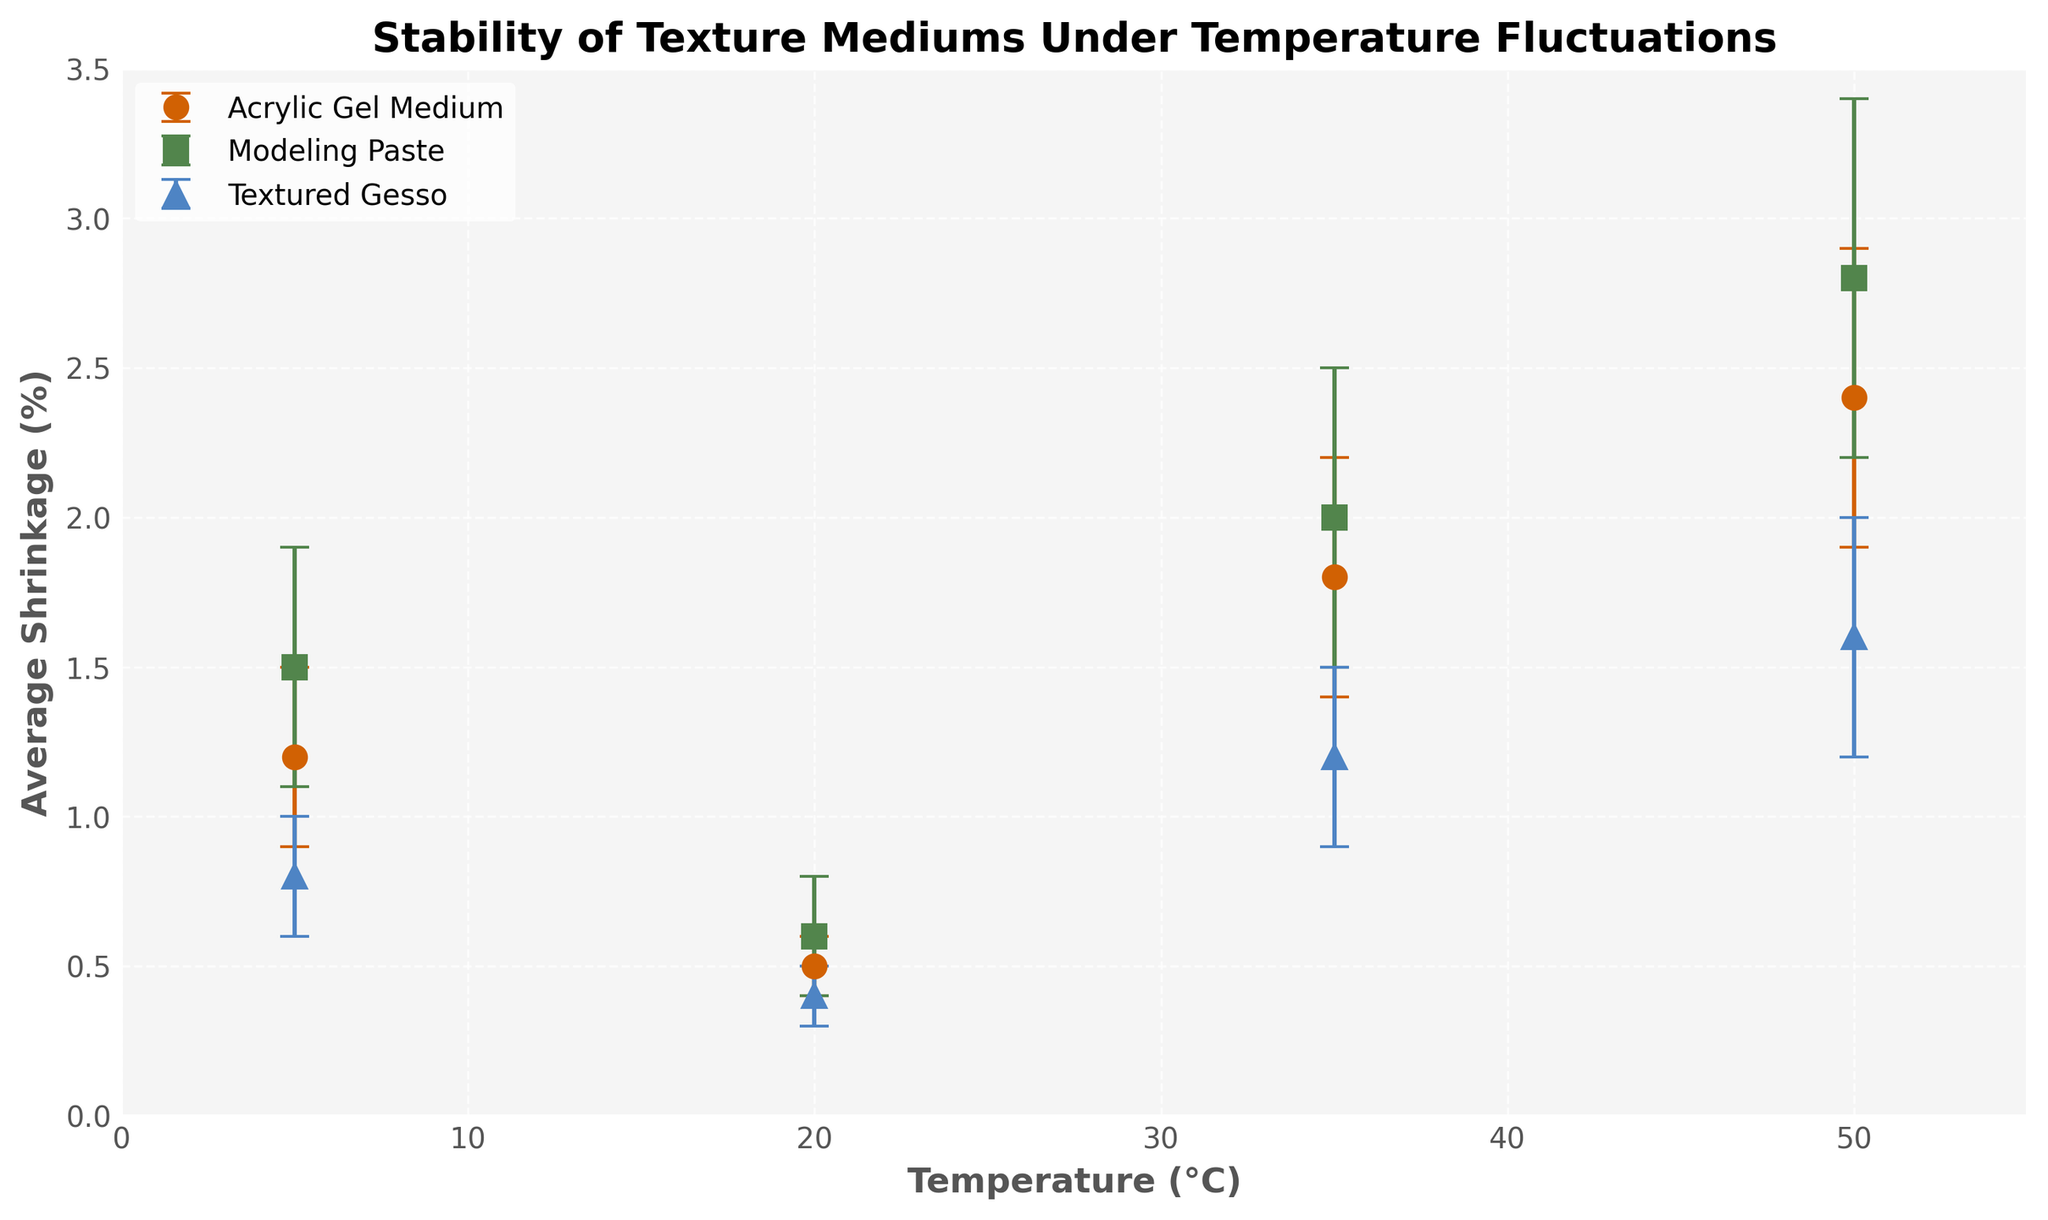what is the title of the figure? The title of the figure is written prominently at the top of the plot.
Answer: Stability of Texture Mediums Under Temperature Fluctuations How does the average shrinkage of Modeling Paste behave as temperature increases from 5°C to 50°C? By observing the points related to Modeling Paste marked with squares, we see an increase in average shrinkage from 1.5% to 2.8%.
Answer: it increases Which medium has the lowest average shrinkage at 20°C, and what is its value? By looking at the data points at 20°C, the lowest average shrinkage value (0.4%) is for Textured Gesso.
Answer: Textured Gesso, 0.4% how many temperature points were measured for each medium? Each medium has data points at 5°C, 20°C, 35°C, and 50°C, which makes it four temperature measurements for each medium.
Answer: four At which temperature does Acrylic Gel Medium experience the highest average shrinkage, and what is the value? Examining the points for Acrylic Gel Medium, the highest average shrinkage occurs at 50°C with a value of 2.4%.
Answer: 50°C, 2.4% What is the range of average shrinkage for Textured Gesso across the measured temperatures? By checking the highest and lowest points for Textured Gesso, the range is 1.6% - 0.4% = 1.2%.
Answer: 1.2% Compare the average shrinkage between Acrylic Gel Medium and Modeling Paste at 35°C. Which one is higher and by how much? The average shrinkage for Acrylic Gel Medium at 35°C is 1.8%, and for Modeling Paste, it is 2.0%. Thus, Modeling Paste is higher by 2.0% - 1.8% = 0.2%.
Answer: Modeling Paste, 0.2% What can be inferred about the stability of Textured Gesso compared to Acrylic Gel Medium as temperature increases? Noting the changes, Textured Gesso has overall lower average shrinkage values and smaller increases than Acrylic Gel Medium, indicating better stability under rising temperatures.
Answer: Textured Gesso is more stable 